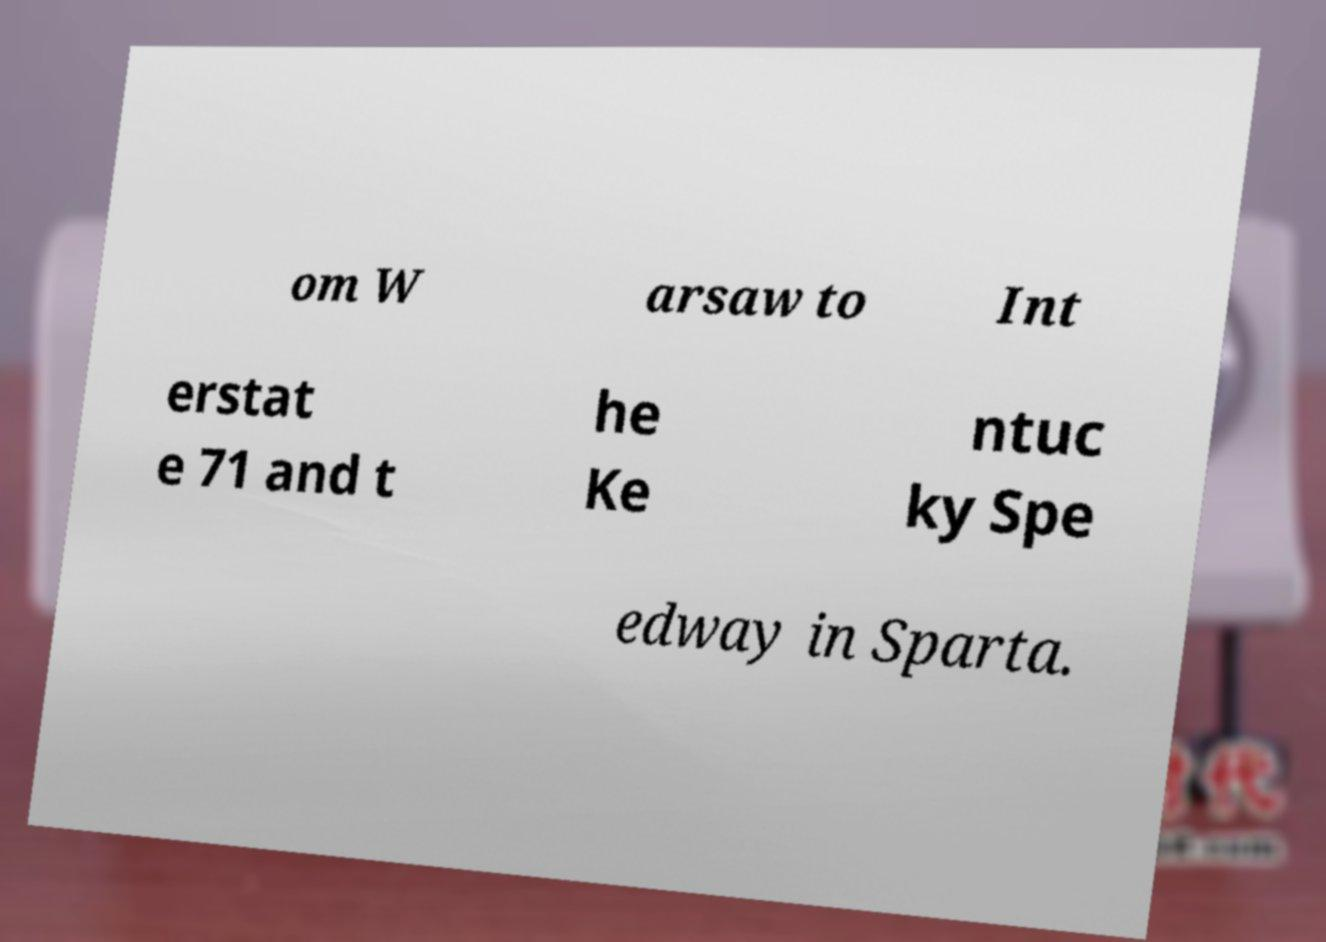Can you read and provide the text displayed in the image?This photo seems to have some interesting text. Can you extract and type it out for me? om W arsaw to Int erstat e 71 and t he Ke ntuc ky Spe edway in Sparta. 